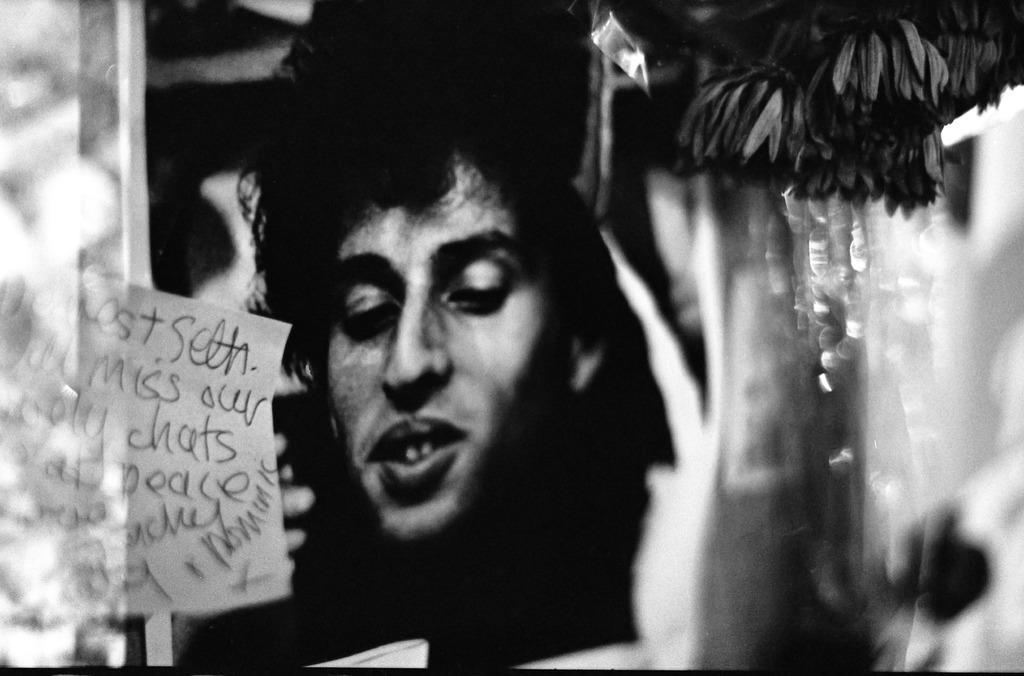Could you give a brief overview of what you see in this image? It is the black and white image in which we can see the face of a person. On the left side there is a paper on which there is some script. On the right side top there are flowers. On the left side it looks blurry. 